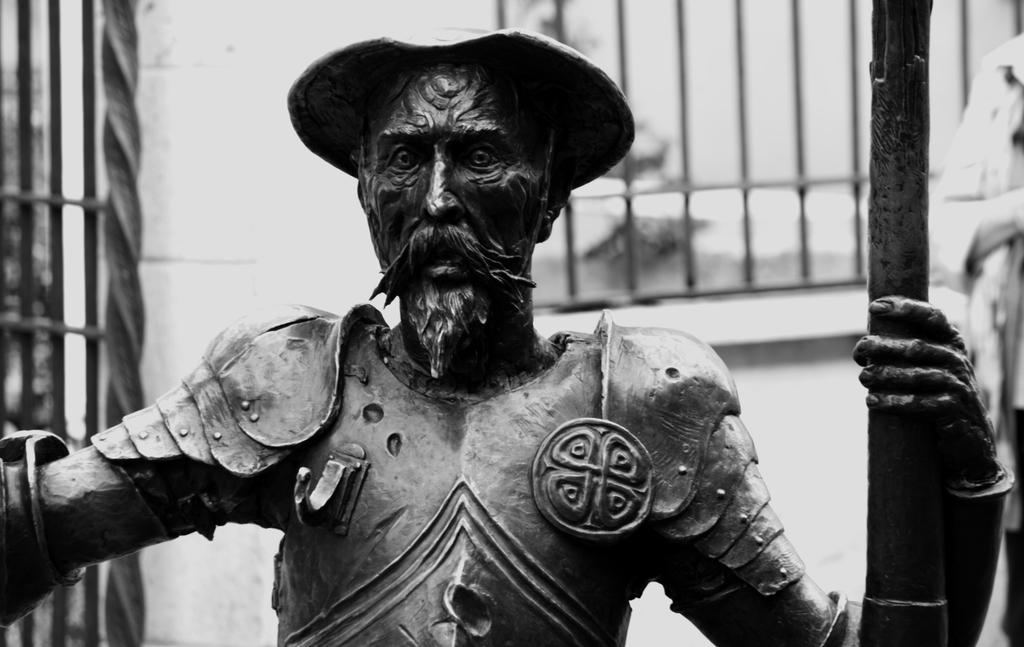What is the main subject in the image? There is a statue in the image. What can be seen in the background of the image? There are railings in the background of the image. What type of pet is sitting on the statue's lap in the image? There is no pet present on the statue's lap in the image. 